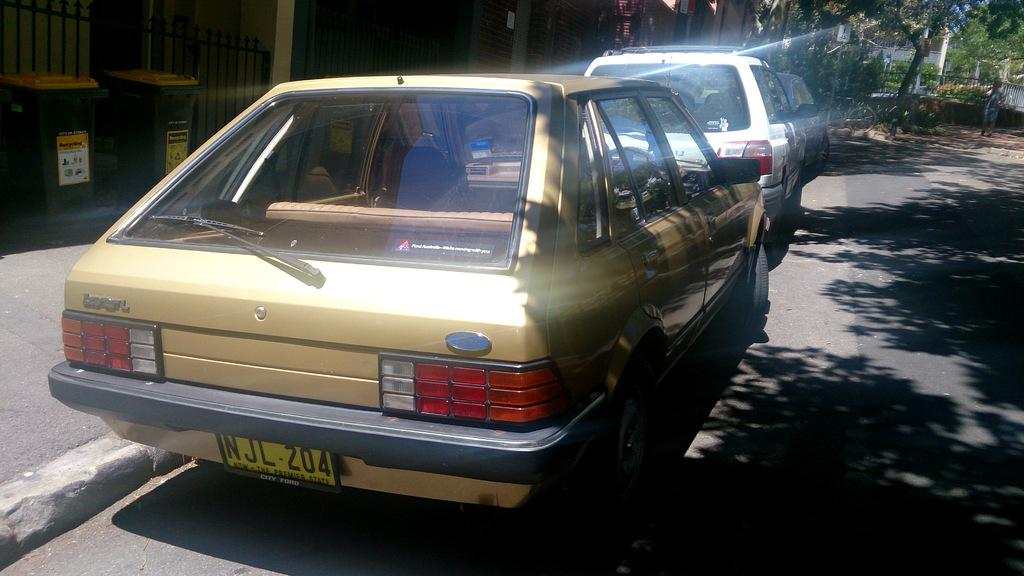What type of vehicles can be seen in the image? There are cars parked in the image. What structures are visible in the image? There are buildings visible in the image. What type of vegetation is present in the image? There are trees in the image. What mode of transportation can be seen in addition to cars? There is a bicycle in the image. Is there a person present in the image? Yes, there is a human standing in the image. What objects are present for waste disposal in the image? There are dustbins in the image. Can you describe the waves crashing on the coast in the image? There are no waves or coast visible in the image; it features cars, buildings, trees, a bicycle, a human, and dustbins. Is there a bomb present in the image? There is no bomb present in the image. 